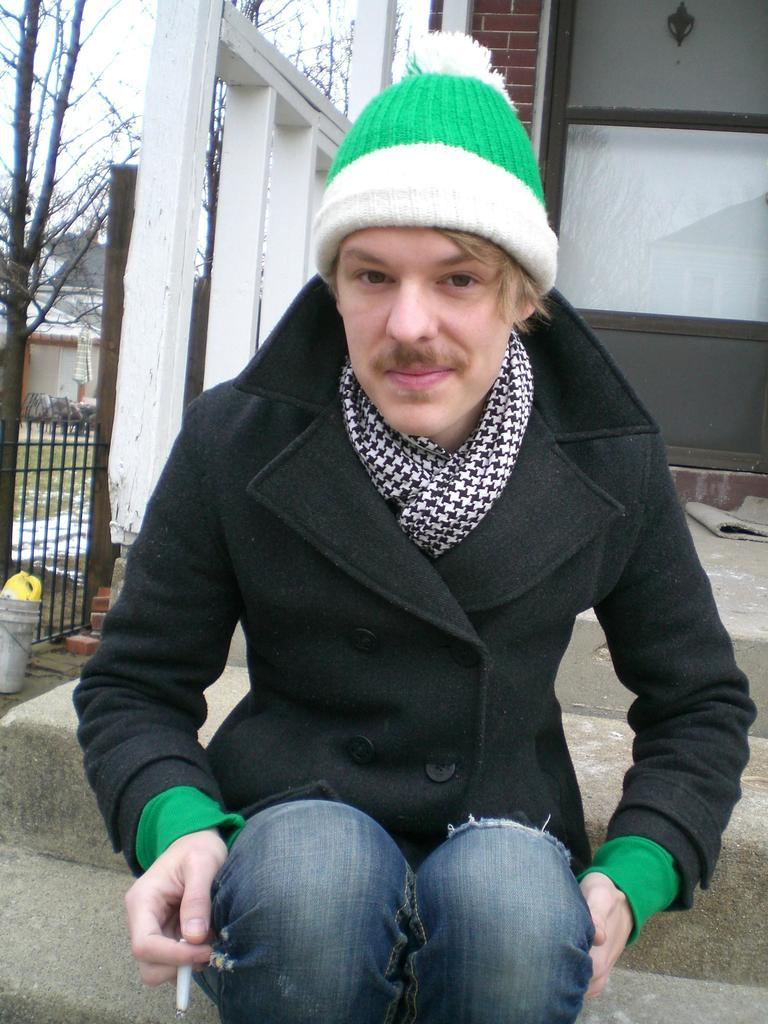What is the main subject of the image? There is a man in the image. What is the man wearing? The man is wearing a black jacket. What is the man holding in the image? The man is holding a cigarette. What can be seen in the background of the image? There is a wall, a fence, trees, and the sky visible in the background of the image. What type of berry is the man eating in the image? There is no berry present in the image; the man is holding a cigarette. What is the heart rate of the monkey in the image? There is no monkey present in the image, so it is not possible to determine its heart rate. 